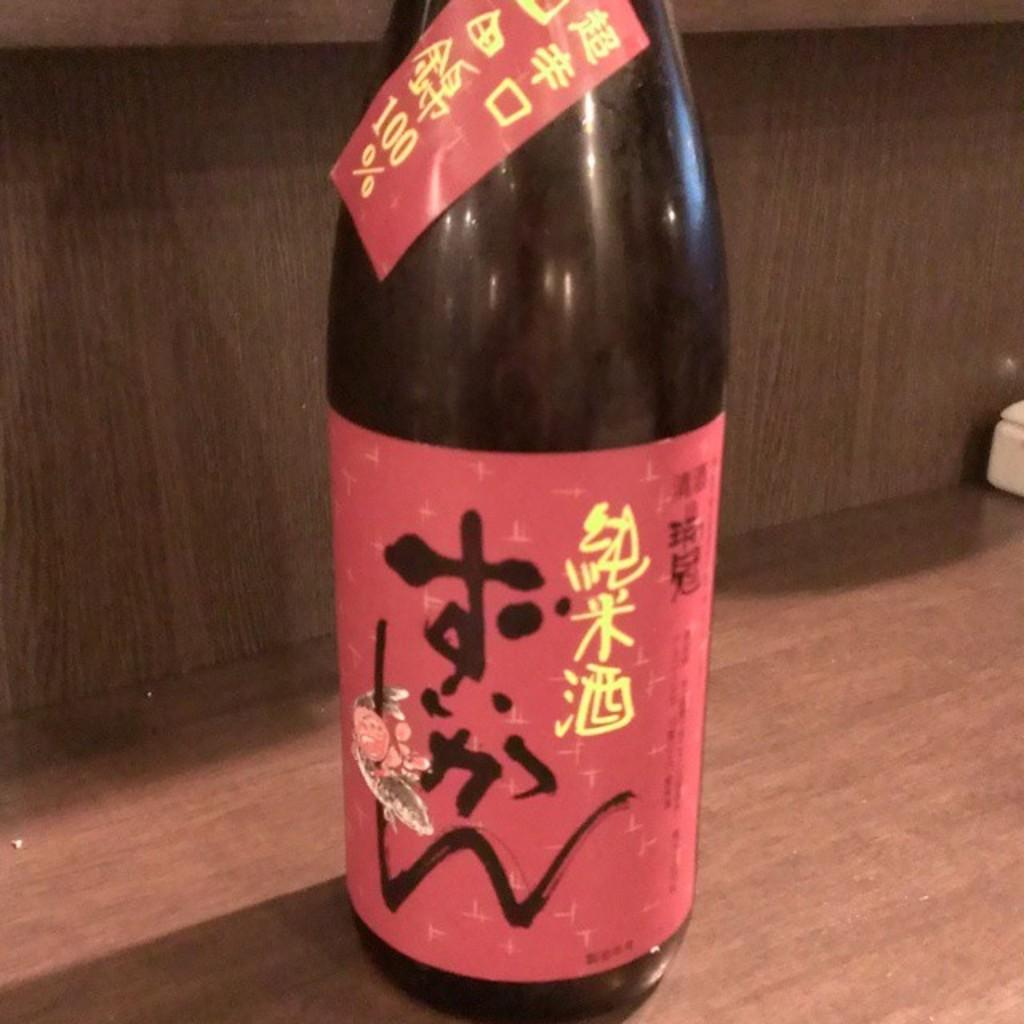<image>
Summarize the visual content of the image. A foreign beer bottle that has the percentage of 100 on it 